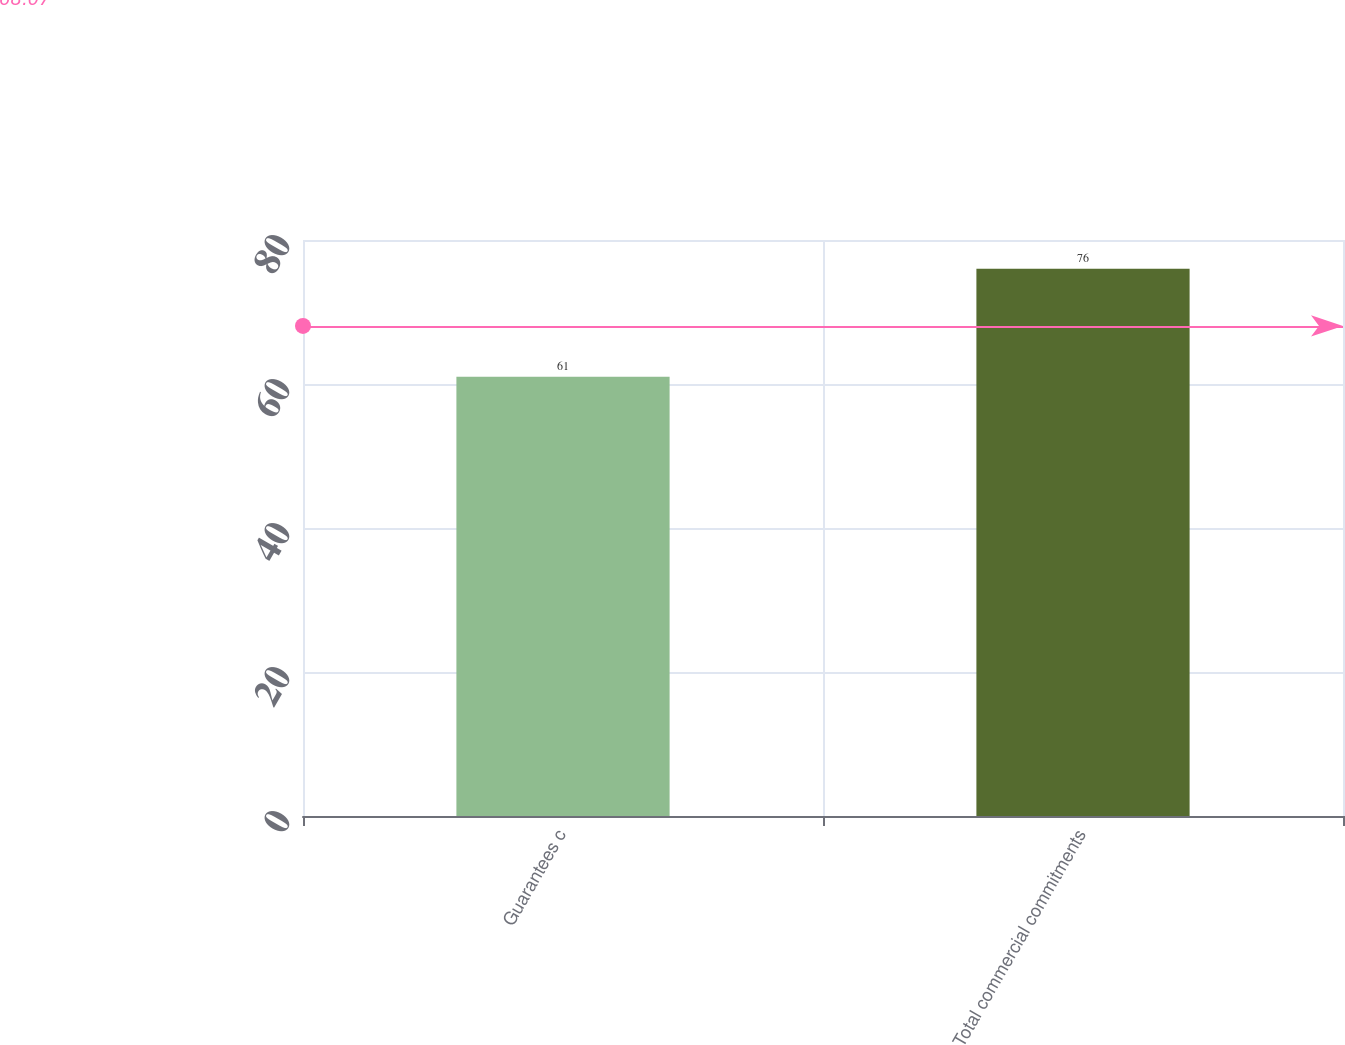Convert chart to OTSL. <chart><loc_0><loc_0><loc_500><loc_500><bar_chart><fcel>Guarantees c<fcel>Total commercial commitments<nl><fcel>61<fcel>76<nl></chart> 